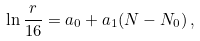<formula> <loc_0><loc_0><loc_500><loc_500>\ln \frac { r } { 1 6 } = a _ { 0 } + a _ { 1 } ( N - N _ { 0 } ) \, ,</formula> 